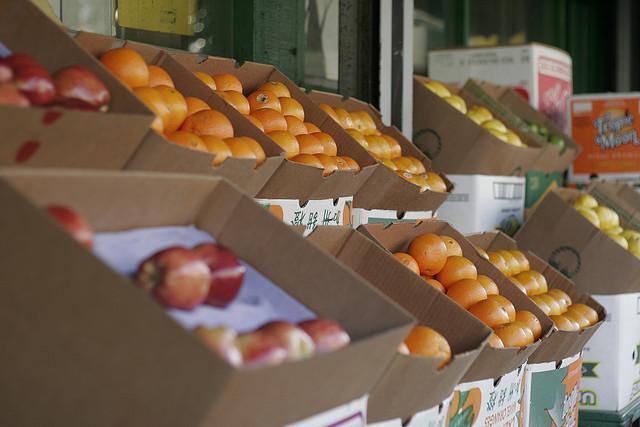How many oranges are there?
Give a very brief answer. 3. How many apples are there?
Give a very brief answer. 3. How many baby elephants are there?
Give a very brief answer. 0. 